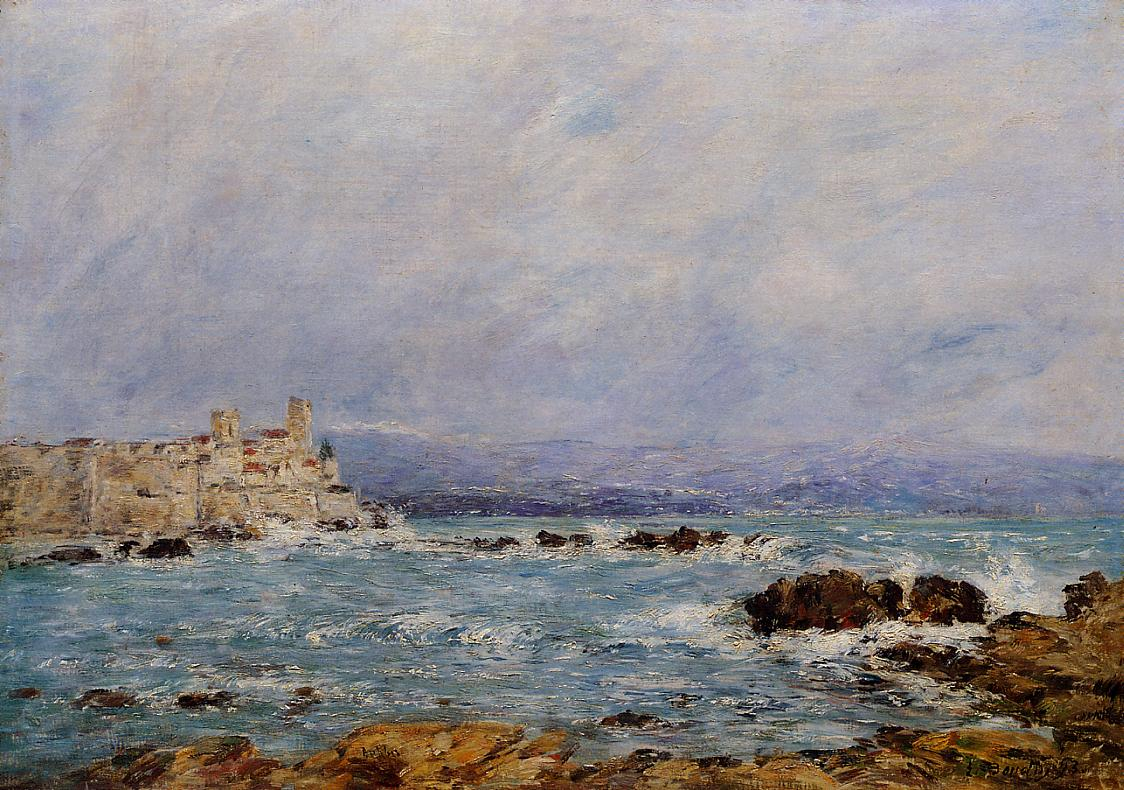Can you tell more about the historical significance of the fortress in this painting? Certainly! The fortress depicted in this painting likely holds a storied past as a fortification on the coast. While the specific history is not clearly provided, such structures typically were pivotal in defending territories against invasions by sea. In Monet's time, these castles would have been symbols of historical resilience and power. The placement of the fortress, enduring atop rugged rocks, could be seen as a metaphor for human tenacity in the face of natural and historical tumult, a theme often subtly explored in landscape art from this era. 